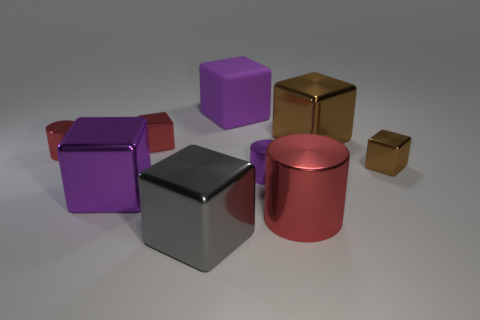Can you describe the lighting setup that's illuminating these objects? The objects are being lit by a soft and diffuse light source, as indicated by the gentle shadows and subtle reflections. This type of lighting suggests an indoor setting with either natural light filtering through a window or artificial light from overhead fixtures that are not directly visible. 